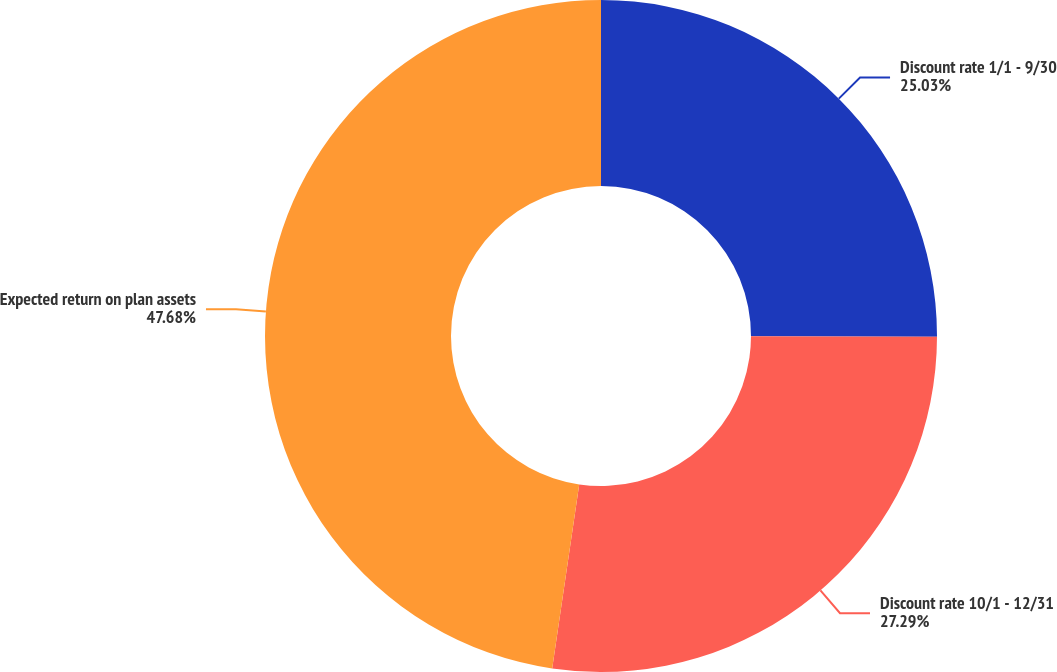Convert chart to OTSL. <chart><loc_0><loc_0><loc_500><loc_500><pie_chart><fcel>Discount rate 1/1 - 9/30<fcel>Discount rate 10/1 - 12/31<fcel>Expected return on plan assets<nl><fcel>25.03%<fcel>27.29%<fcel>47.68%<nl></chart> 